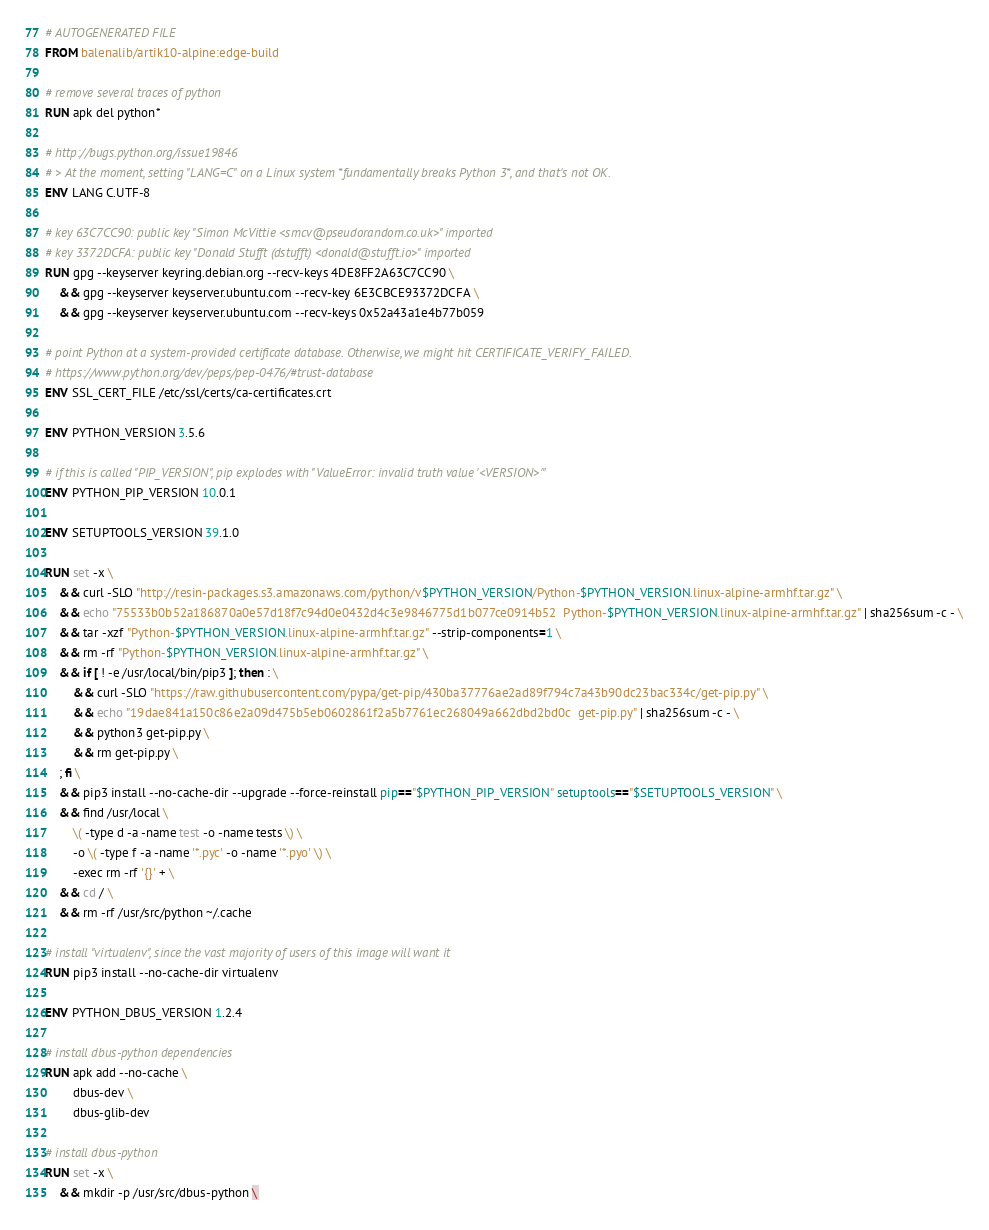Convert code to text. <code><loc_0><loc_0><loc_500><loc_500><_Dockerfile_># AUTOGENERATED FILE
FROM balenalib/artik10-alpine:edge-build

# remove several traces of python
RUN apk del python*

# http://bugs.python.org/issue19846
# > At the moment, setting "LANG=C" on a Linux system *fundamentally breaks Python 3*, and that's not OK.
ENV LANG C.UTF-8

# key 63C7CC90: public key "Simon McVittie <smcv@pseudorandom.co.uk>" imported
# key 3372DCFA: public key "Donald Stufft (dstufft) <donald@stufft.io>" imported
RUN gpg --keyserver keyring.debian.org --recv-keys 4DE8FF2A63C7CC90 \
	&& gpg --keyserver keyserver.ubuntu.com --recv-key 6E3CBCE93372DCFA \
	&& gpg --keyserver keyserver.ubuntu.com --recv-keys 0x52a43a1e4b77b059

# point Python at a system-provided certificate database. Otherwise, we might hit CERTIFICATE_VERIFY_FAILED.
# https://www.python.org/dev/peps/pep-0476/#trust-database
ENV SSL_CERT_FILE /etc/ssl/certs/ca-certificates.crt

ENV PYTHON_VERSION 3.5.6

# if this is called "PIP_VERSION", pip explodes with "ValueError: invalid truth value '<VERSION>'"
ENV PYTHON_PIP_VERSION 10.0.1

ENV SETUPTOOLS_VERSION 39.1.0

RUN set -x \
	&& curl -SLO "http://resin-packages.s3.amazonaws.com/python/v$PYTHON_VERSION/Python-$PYTHON_VERSION.linux-alpine-armhf.tar.gz" \
	&& echo "75533b0b52a186870a0e57d18f7c94d0e0432d4c3e9846775d1b077ce0914b52  Python-$PYTHON_VERSION.linux-alpine-armhf.tar.gz" | sha256sum -c - \
	&& tar -xzf "Python-$PYTHON_VERSION.linux-alpine-armhf.tar.gz" --strip-components=1 \
	&& rm -rf "Python-$PYTHON_VERSION.linux-alpine-armhf.tar.gz" \
	&& if [ ! -e /usr/local/bin/pip3 ]; then : \
		&& curl -SLO "https://raw.githubusercontent.com/pypa/get-pip/430ba37776ae2ad89f794c7a43b90dc23bac334c/get-pip.py" \
		&& echo "19dae841a150c86e2a09d475b5eb0602861f2a5b7761ec268049a662dbd2bd0c  get-pip.py" | sha256sum -c - \
		&& python3 get-pip.py \
		&& rm get-pip.py \
	; fi \
	&& pip3 install --no-cache-dir --upgrade --force-reinstall pip=="$PYTHON_PIP_VERSION" setuptools=="$SETUPTOOLS_VERSION" \
	&& find /usr/local \
		\( -type d -a -name test -o -name tests \) \
		-o \( -type f -a -name '*.pyc' -o -name '*.pyo' \) \
		-exec rm -rf '{}' + \
	&& cd / \
	&& rm -rf /usr/src/python ~/.cache

# install "virtualenv", since the vast majority of users of this image will want it
RUN pip3 install --no-cache-dir virtualenv

ENV PYTHON_DBUS_VERSION 1.2.4

# install dbus-python dependencies 
RUN apk add --no-cache \
		dbus-dev \
		dbus-glib-dev

# install dbus-python
RUN set -x \
	&& mkdir -p /usr/src/dbus-python \</code> 